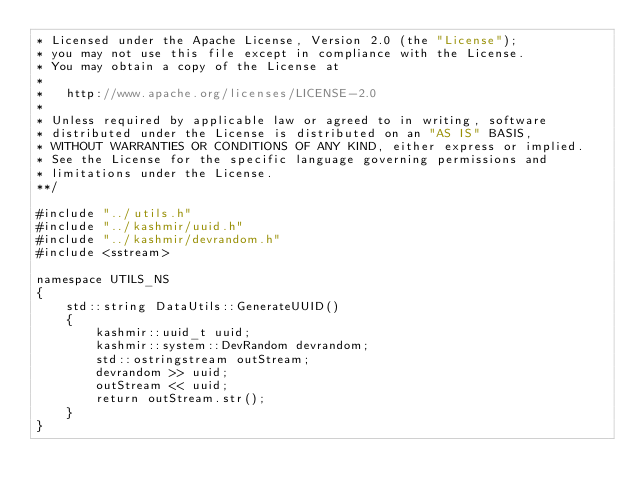<code> <loc_0><loc_0><loc_500><loc_500><_ObjectiveC_>* Licensed under the Apache License, Version 2.0 (the "License");
* you may not use this file except in compliance with the License.
* You may obtain a copy of the License at
*
*   http://www.apache.org/licenses/LICENSE-2.0
*
* Unless required by applicable law or agreed to in writing, software
* distributed under the License is distributed on an "AS IS" BASIS,
* WITHOUT WARRANTIES OR CONDITIONS OF ANY KIND, either express or implied.
* See the License for the specific language governing permissions and
* limitations under the License.
**/

#include "../utils.h"
#include "../kashmir/uuid.h"
#include "../kashmir/devrandom.h"
#include <sstream>

namespace UTILS_NS
{
    std::string DataUtils::GenerateUUID()
    {
        kashmir::uuid_t uuid;
        kashmir::system::DevRandom devrandom;
        std::ostringstream outStream;
        devrandom >> uuid;
        outStream << uuid;
        return outStream.str();
    }
}</code> 